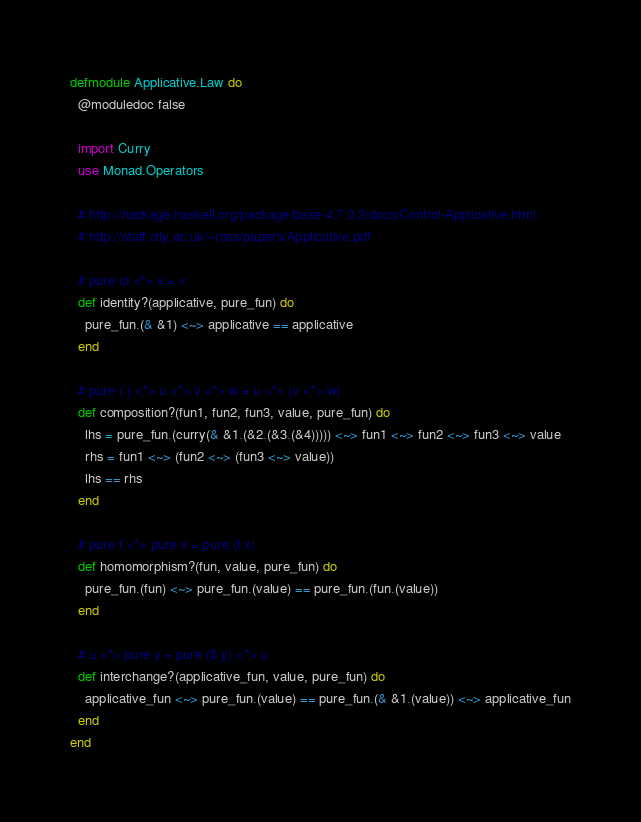<code> <loc_0><loc_0><loc_500><loc_500><_Elixir_>defmodule Applicative.Law do
  @moduledoc false

  import Curry
  use Monad.Operators

  # http://hackage.haskell.org/package/base-4.7.0.2/docs/Control-Applicative.html
  # http://staff.city.ac.uk/~ross/papers/Applicative.pdf

  # pure id <*> v = v
  def identity?(applicative, pure_fun) do
    pure_fun.(& &1) <~> applicative == applicative
  end

  # pure (.) <*> u <*> v <*> w = u <*> (v <*> w)
  def composition?(fun1, fun2, fun3, value, pure_fun) do
    lhs = pure_fun.(curry(& &1.(&2.(&3.(&4))))) <~> fun1 <~> fun2 <~> fun3 <~> value
    rhs = fun1 <~> (fun2 <~> (fun3 <~> value))
    lhs == rhs
  end

  # pure f <*> pure x = pure (f x)
  def homomorphism?(fun, value, pure_fun) do
    pure_fun.(fun) <~> pure_fun.(value) == pure_fun.(fun.(value))
  end

  # u <*> pure y = pure ($ y) <*> u
  def interchange?(applicative_fun, value, pure_fun) do
    applicative_fun <~> pure_fun.(value) == pure_fun.(& &1.(value)) <~> applicative_fun
  end
end
</code> 